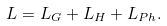Convert formula to latex. <formula><loc_0><loc_0><loc_500><loc_500>L = L _ { G } + L _ { H } + L _ { P h } .</formula> 